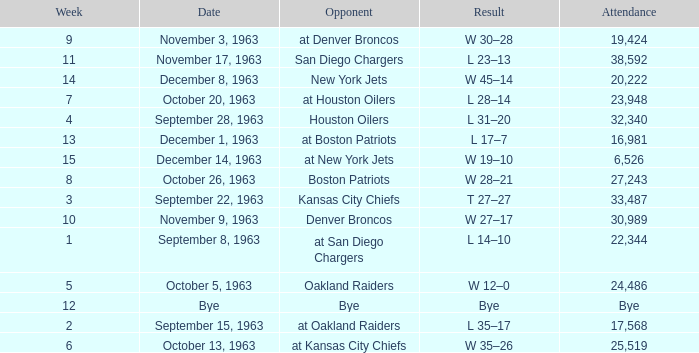Which Opponent has a Result of w 19–10? At new york jets. Parse the table in full. {'header': ['Week', 'Date', 'Opponent', 'Result', 'Attendance'], 'rows': [['9', 'November 3, 1963', 'at Denver Broncos', 'W 30–28', '19,424'], ['11', 'November 17, 1963', 'San Diego Chargers', 'L 23–13', '38,592'], ['14', 'December 8, 1963', 'New York Jets', 'W 45–14', '20,222'], ['7', 'October 20, 1963', 'at Houston Oilers', 'L 28–14', '23,948'], ['4', 'September 28, 1963', 'Houston Oilers', 'L 31–20', '32,340'], ['13', 'December 1, 1963', 'at Boston Patriots', 'L 17–7', '16,981'], ['15', 'December 14, 1963', 'at New York Jets', 'W 19–10', '6,526'], ['8', 'October 26, 1963', 'Boston Patriots', 'W 28–21', '27,243'], ['3', 'September 22, 1963', 'Kansas City Chiefs', 'T 27–27', '33,487'], ['10', 'November 9, 1963', 'Denver Broncos', 'W 27–17', '30,989'], ['1', 'September 8, 1963', 'at San Diego Chargers', 'L 14–10', '22,344'], ['5', 'October 5, 1963', 'Oakland Raiders', 'W 12–0', '24,486'], ['12', 'Bye', 'Bye', 'Bye', 'Bye'], ['2', 'September 15, 1963', 'at Oakland Raiders', 'L 35–17', '17,568'], ['6', 'October 13, 1963', 'at Kansas City Chiefs', 'W 35–26', '25,519']]} 